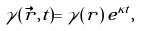<formula> <loc_0><loc_0><loc_500><loc_500>\gamma ( \vec { r } , t ) = \gamma ( r ) \, e ^ { \kappa t } ,</formula> 